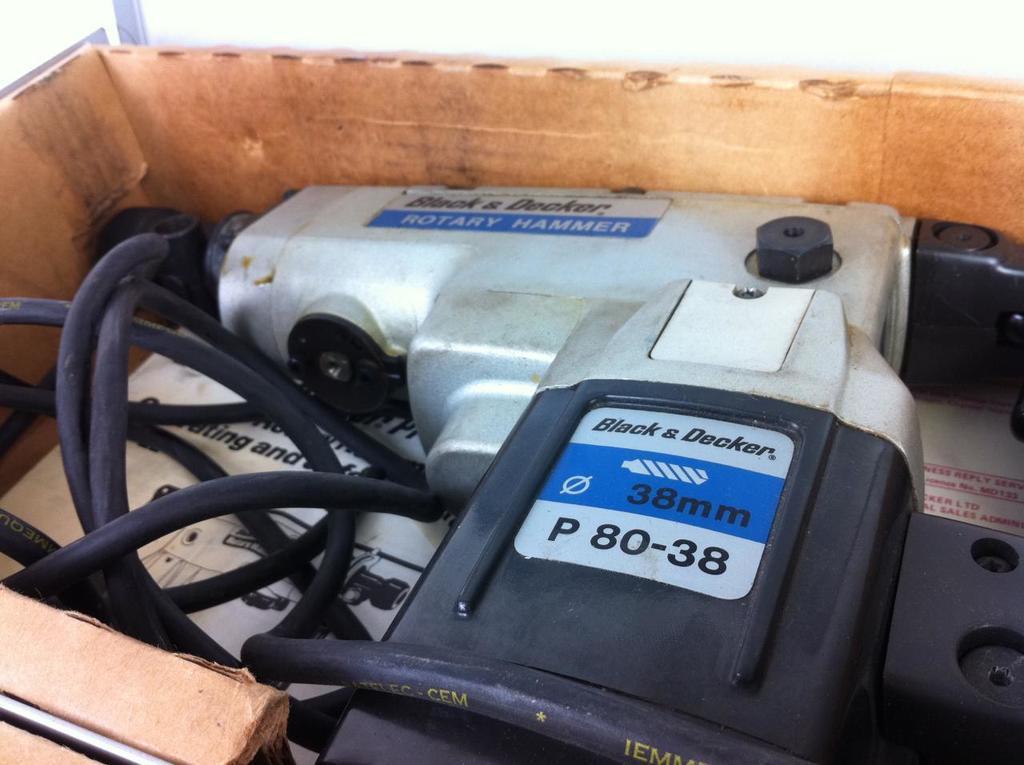Describe this image in one or two sentences. In this image we can see an object looks like a drill machine, there are few wires, paper in the box. 